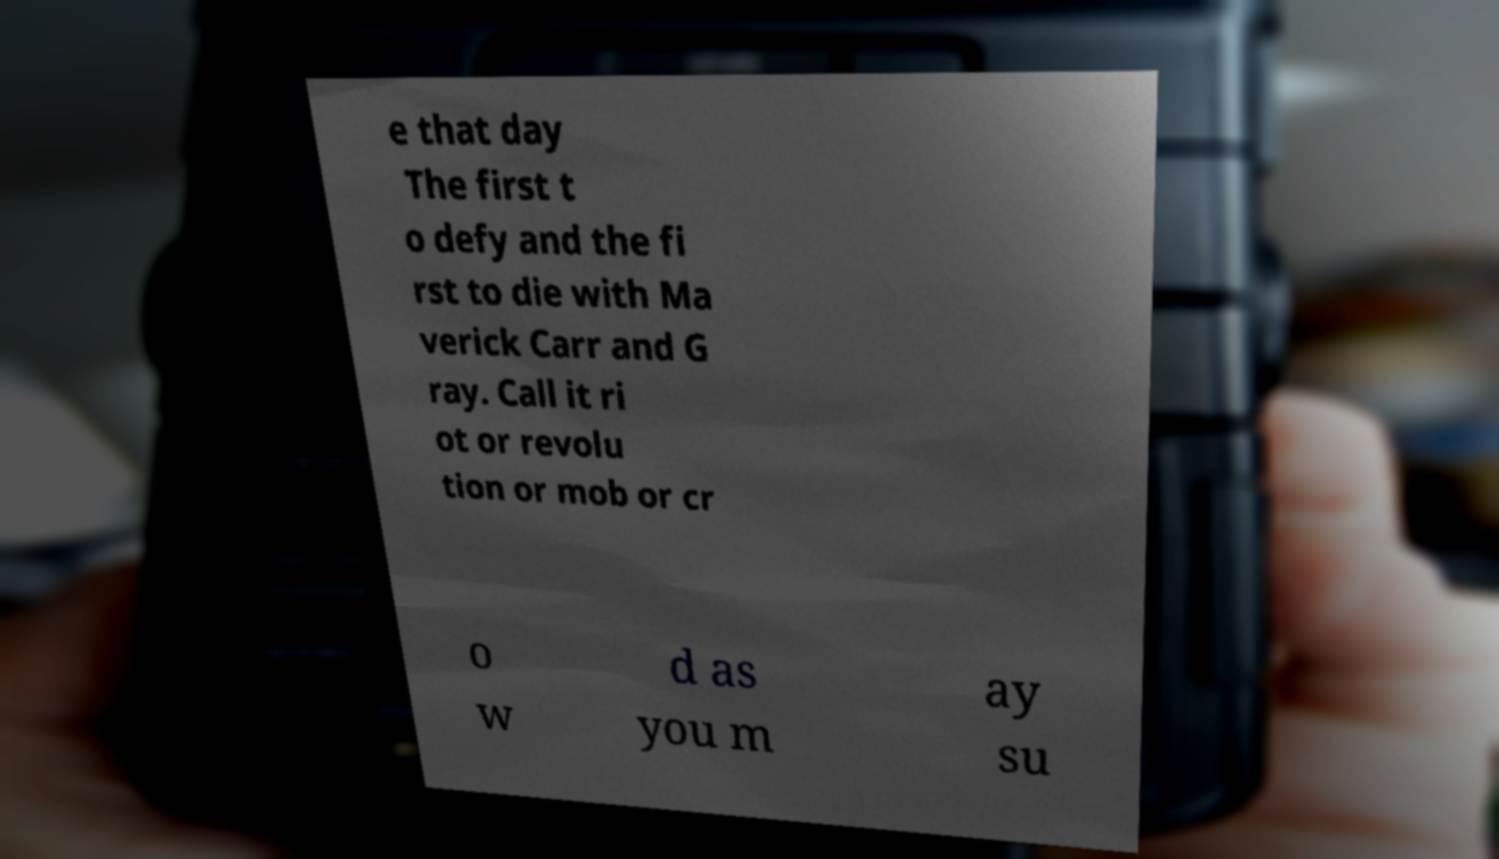For documentation purposes, I need the text within this image transcribed. Could you provide that? e that day The first t o defy and the fi rst to die with Ma verick Carr and G ray. Call it ri ot or revolu tion or mob or cr o w d as you m ay su 